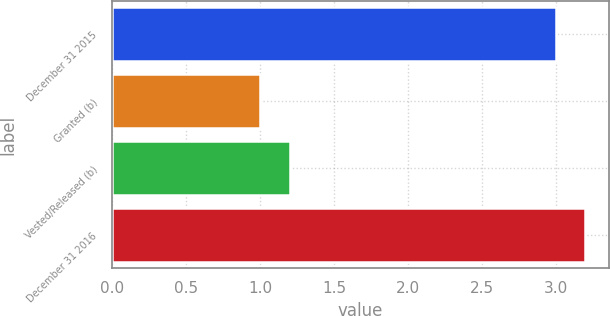<chart> <loc_0><loc_0><loc_500><loc_500><bar_chart><fcel>December 31 2015<fcel>Granted (b)<fcel>Vested/Released (b)<fcel>December 31 2016<nl><fcel>3<fcel>1<fcel>1.2<fcel>3.2<nl></chart> 